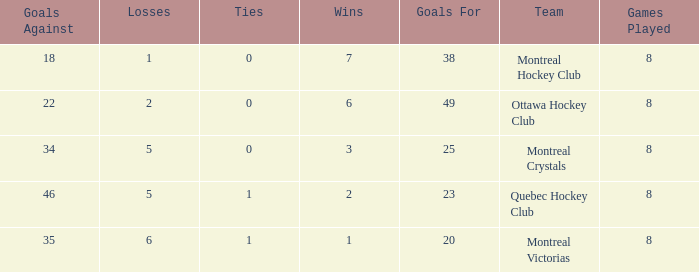What is the total number of goals for when the ties is more than 0, the goals against is more than 35 and the wins is less than 2? 0.0. 